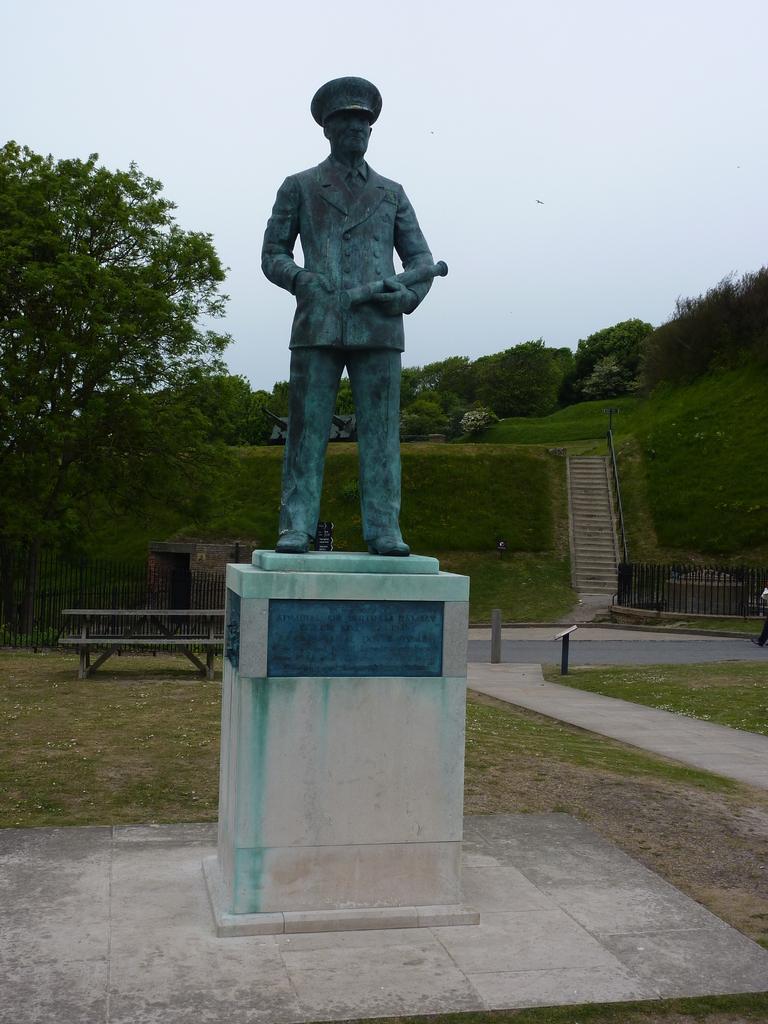In one or two sentences, can you explain what this image depicts? We can see sculpture,on the background we can see fence,bench,trees,grass,steps and sky. 